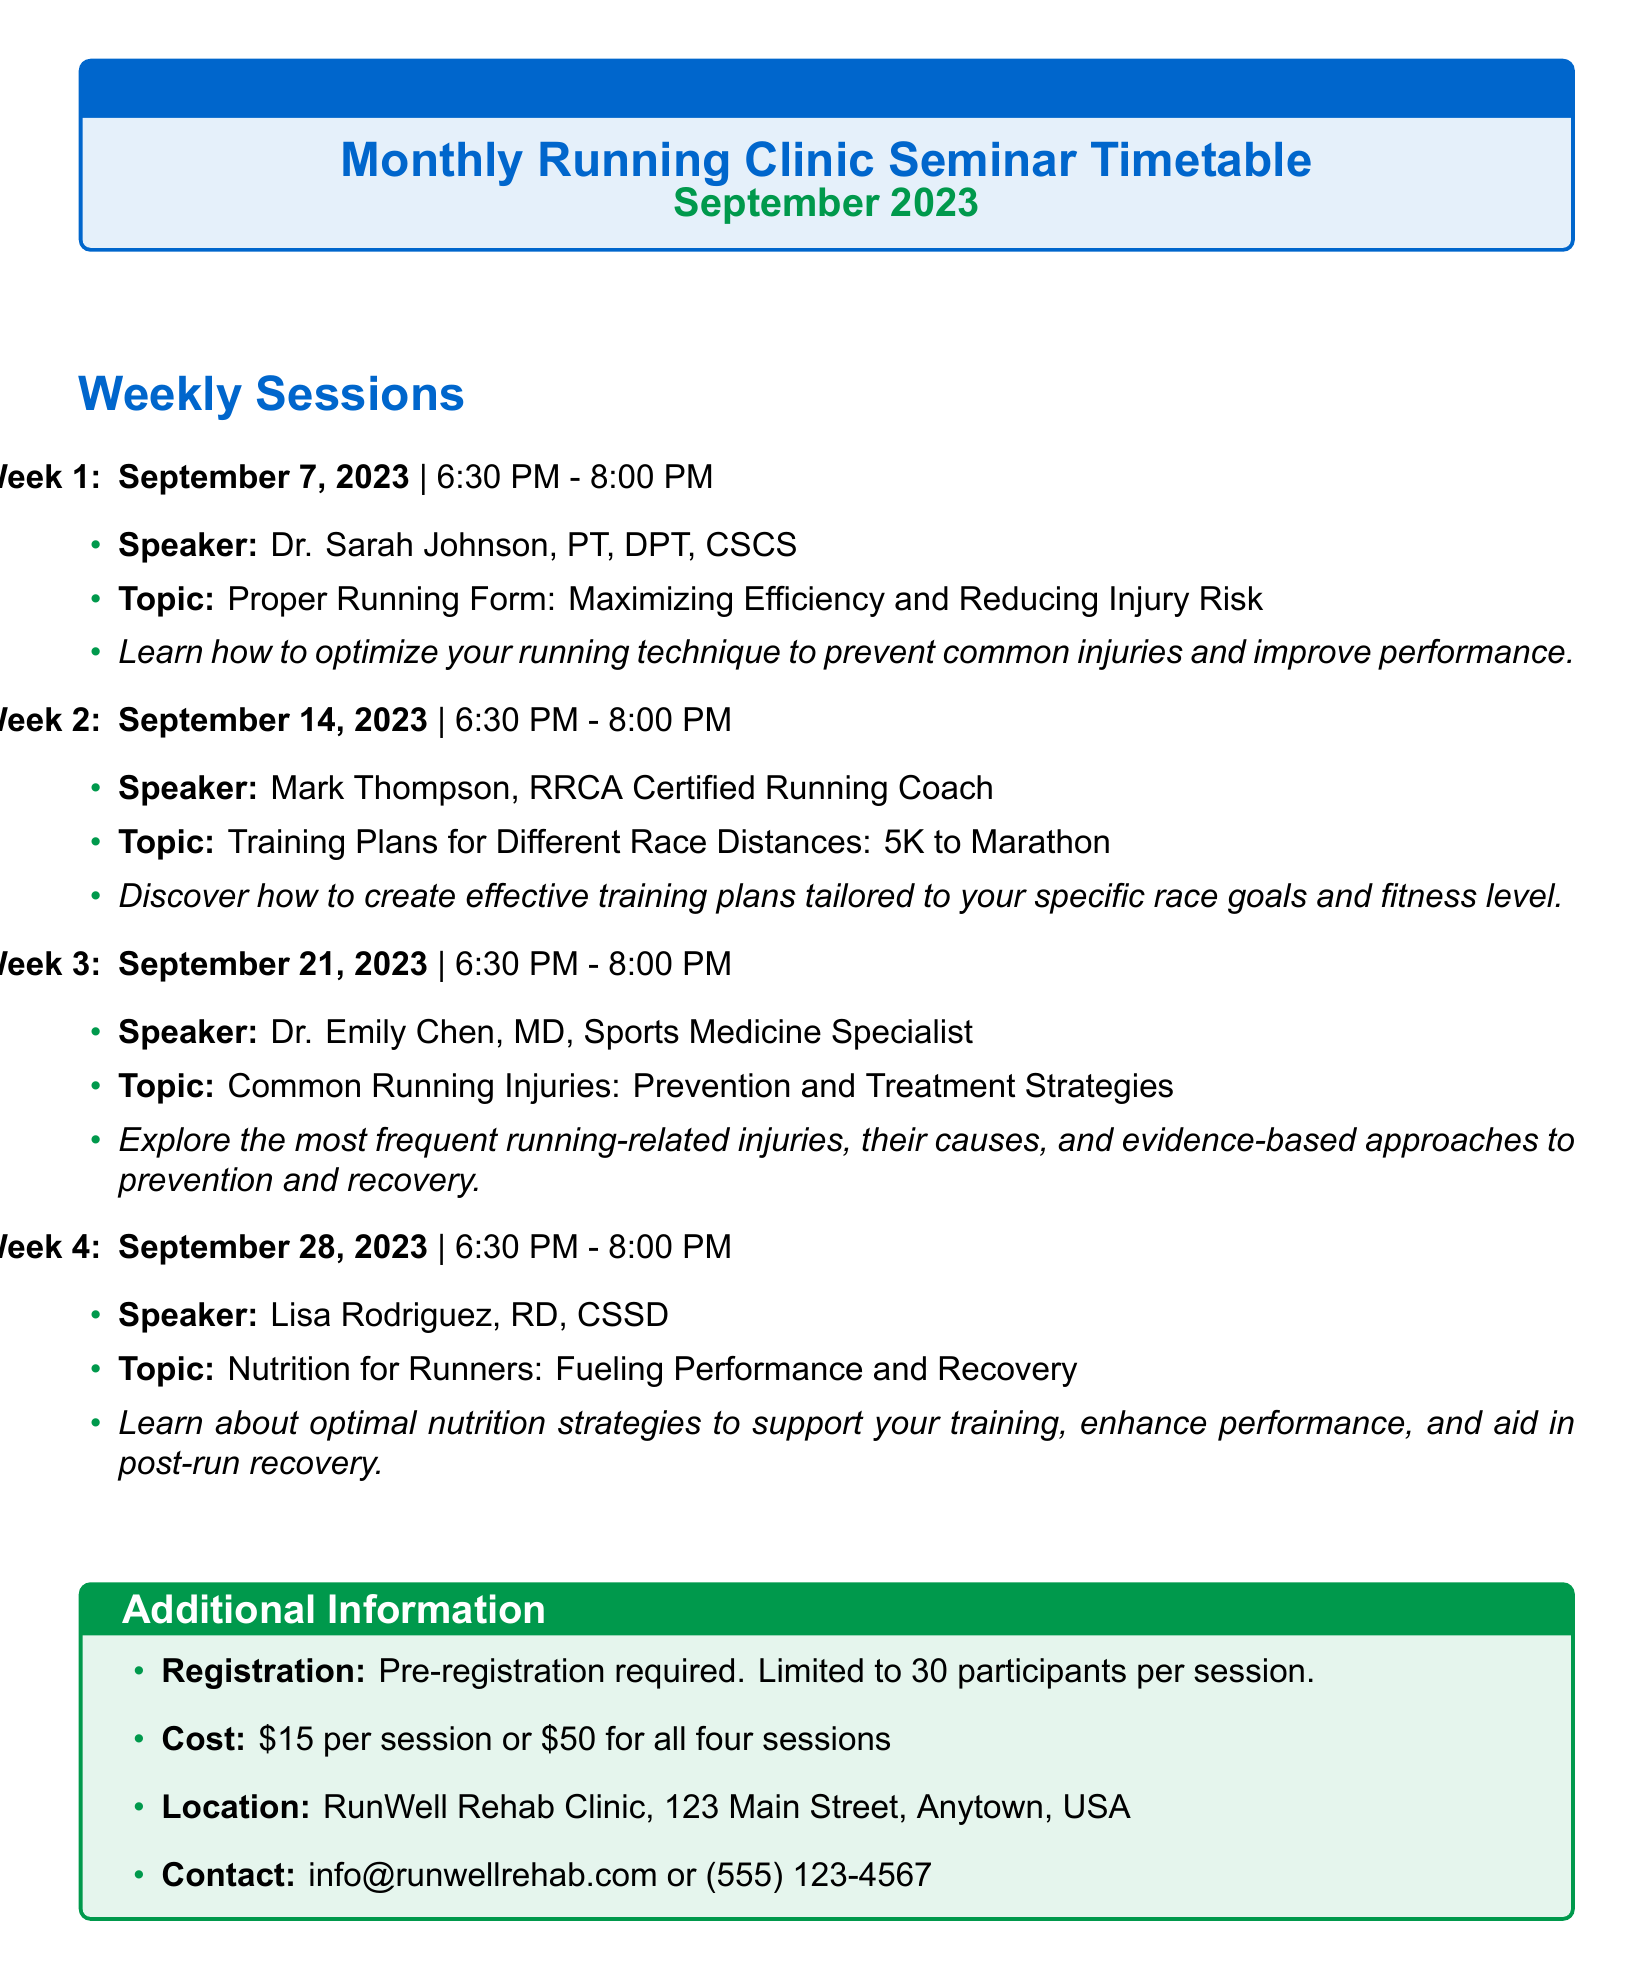what is the name of the clinic? The name of the clinic is stated at the beginning of the document.
Answer: RunWell Rehab Clinic who is the speaker for the third session? The speaker for the third session is listed under the corresponding date and time.
Answer: Dr. Emily Chen what is the topic of the second seminar? The topic of the second seminar is mentioned along with the respective speaker and date.
Answer: Training Plans for Different Race Distances: 5K to Marathon how many participants are limited per session? The limitation on the number of participants per session is detailed in the additional information section.
Answer: 30 participants what is the cost for all four sessions? The total cost for all four sessions is provided in the document.
Answer: $50 for all four sessions when does the fourth seminar take place? The date of the fourth seminar is specified in the schedule.
Answer: September 28, 2023 is pre-registration required? The requirement for pre-registration is stated in the additional information section.
Answer: Yes how long is the free injury screening session? The length of the free injury screening is mentioned under special offers.
Answer: 15 minutes 